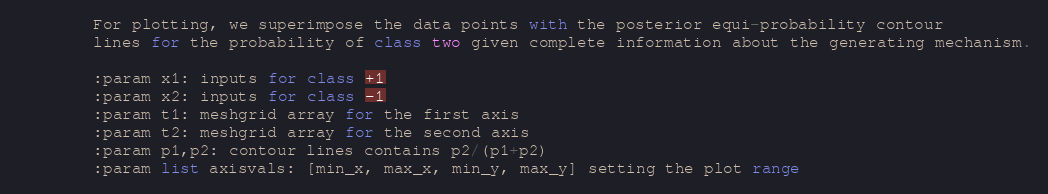<code> <loc_0><loc_0><loc_500><loc_500><_Python_>        For plotting, we superimpose the data points with the posterior equi-probability contour
        lines for the probability of class two given complete information about the generating mechanism.

        :param x1: inputs for class +1
        :param x2: inputs for class -1
        :param t1: meshgrid array for the first axis
        :param t2: meshgrid array for the second axis
        :param p1,p2: contour lines contains p2/(p1+p2)
        :param list axisvals: [min_x, max_x, min_y, max_y] setting the plot range
</code> 